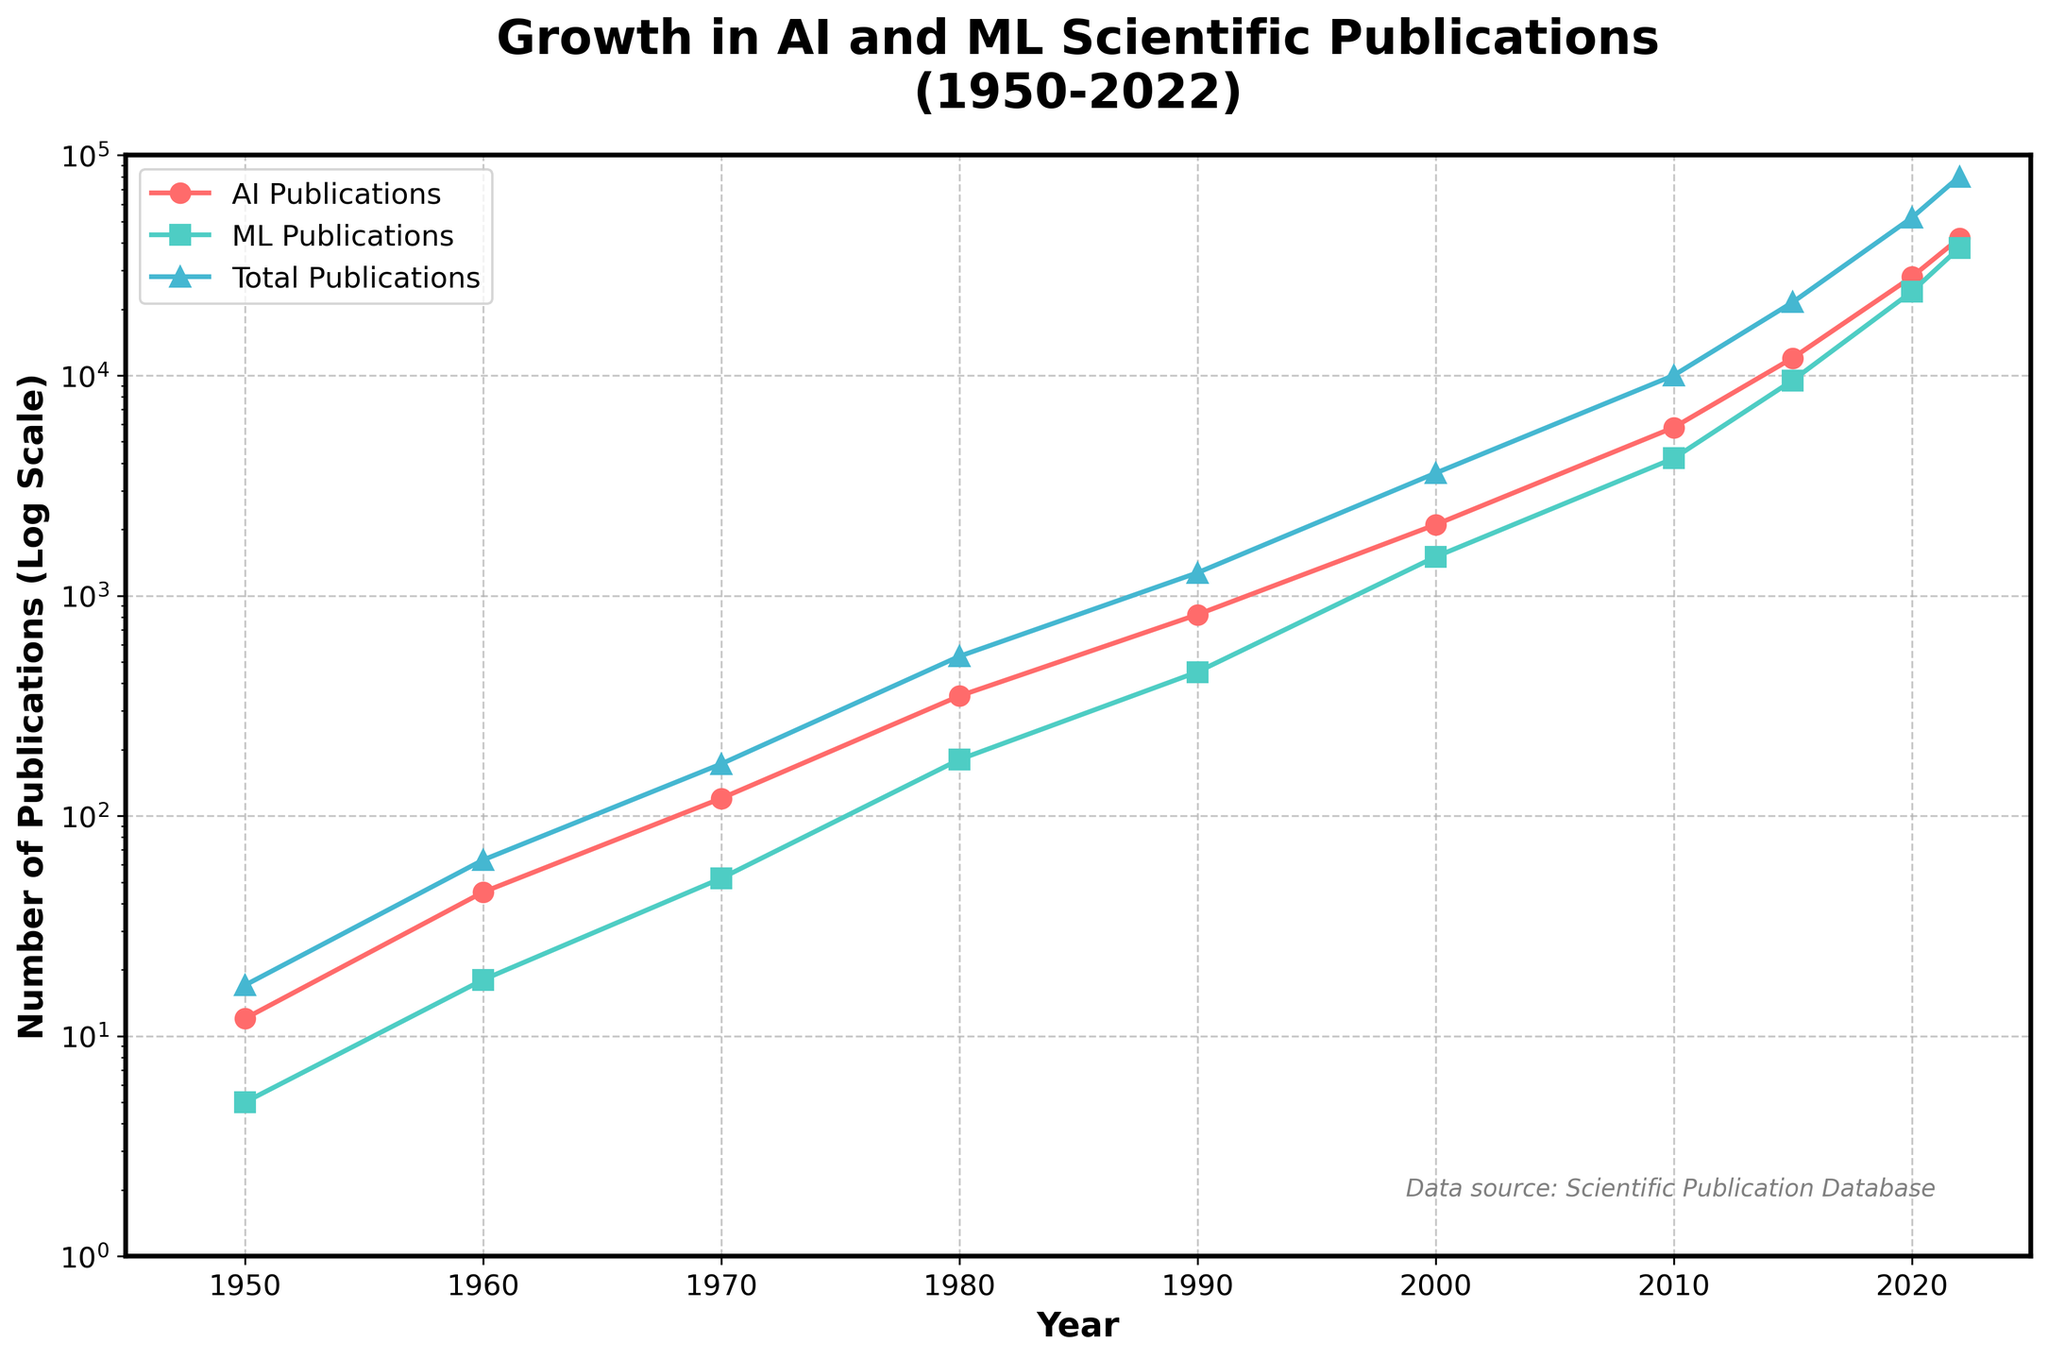1. How many total publications were there in 1980? According to the figure, in 1980, the number of total publications is indicated by the blue line. Referring to the blue line for 1980, we see the value is 530.
Answer: 530 2. By how much did the AI publications increase from 1950 to 2022? The figure shows AI publications in 1950 as 12 and in 2022 as 42,000. Subtract 12 from 42,000: 42,000 - 12 = 41,988.
Answer: 41,988 3. Which year showed a steeper rise in ML publications: between 1970-1980 or 1980-1990? Observing the green line, between 1970 (52 publications) to 1980 (180 publications), the increase is 128 publications. From 1980 to 1990 (450 publications), the increase is 270 publications. Therefore, the rise was steeper between 1980-1990.
Answer: 1980-1990 4. What is the color used to represent AI publications? The line representing AI publications is red in color.
Answer: Red 5. What was the total number of publications in 2022, and how does it compare to the total in 2010? In 2022, the total publications are 80,000 (blue line), and in 2010, it's 10,000. To find the comparison: 80,000 - 10,000 = 70,000. Thus, 2022 had 70,000 more publications than 2010.
Answer: 70,000 more 6. What is the percentage increase in total publications from 2015 to 2022? In 2015, the total publications are 21,500, and in 2022, it's 80,000. To find the percentage increase: ((80,000 - 21,500) / 21,500) * 100 = 272%.
Answer: 272% 7. Which category of publications had more entries in 1990, AI or ML? By how many? In 1990, AI publications are 820 (red line) and ML publications are 450 (green line). AI had more publications. Difference: 820 - 450 = 370.
Answer: AI by 370 8. Describe the general trend of total publications from 1950 to 2022. Observing the blue line, there is a steady increase in total publications starting from a small number in 1950 and sharply rising, especially after 2000, reaching 80,000 in 2022.
Answer: Steadily increasing 9. Between which two consecutive decades did AI publications see the largest absolute increase? Difference during 1950-1960: 33, 1960-1970: 75, 1970-1980: 230, 1980-1990: 470, 1990-2000: 1,280, 2000-2010: 3,700, 2010-2015: 6,200, 2015-2020: 16,000, 2020-2022: 14,000. The largest increase is between 2015-2020 with an increase of 16,000.
Answer: 2015-2020 10. What visual trend is noticeable about ML and AI publications around the early 2000s? Observing the red and green lines, both AI and ML publications start to rise significantly around the early 2000s, marking the beginning of a steep upward trend.
Answer: Significant rise 